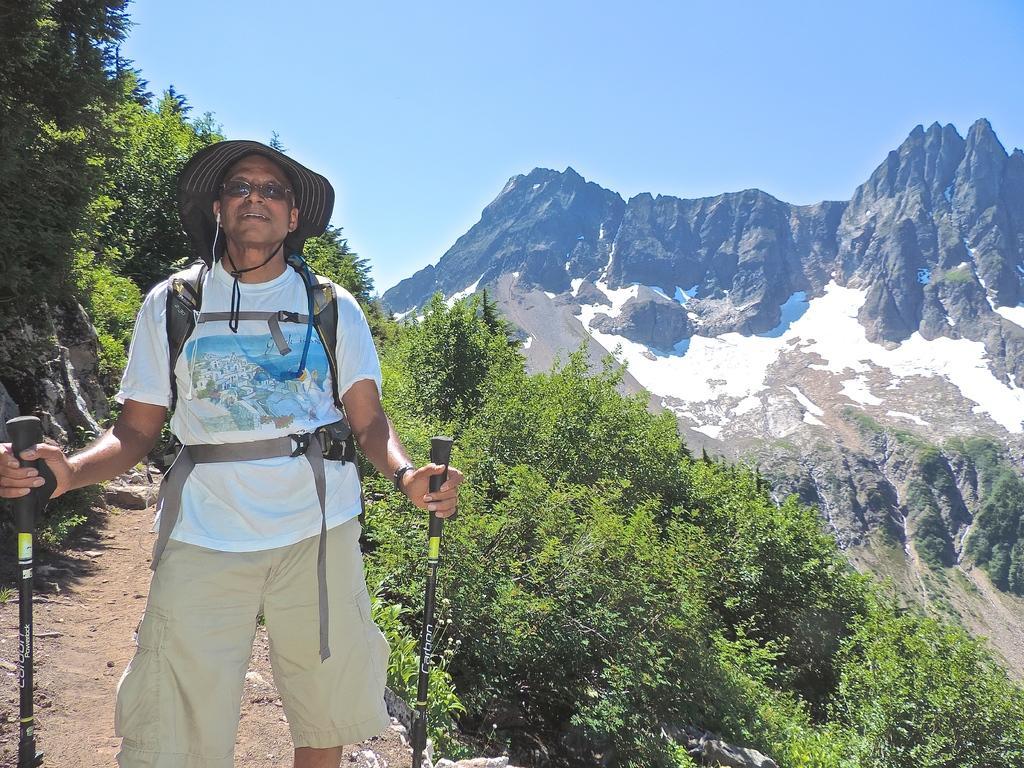Can you describe this image briefly? In this picture is wearing trekking equipment is standing and in the background we observe beautiful scenic places which include mountains , trees. 